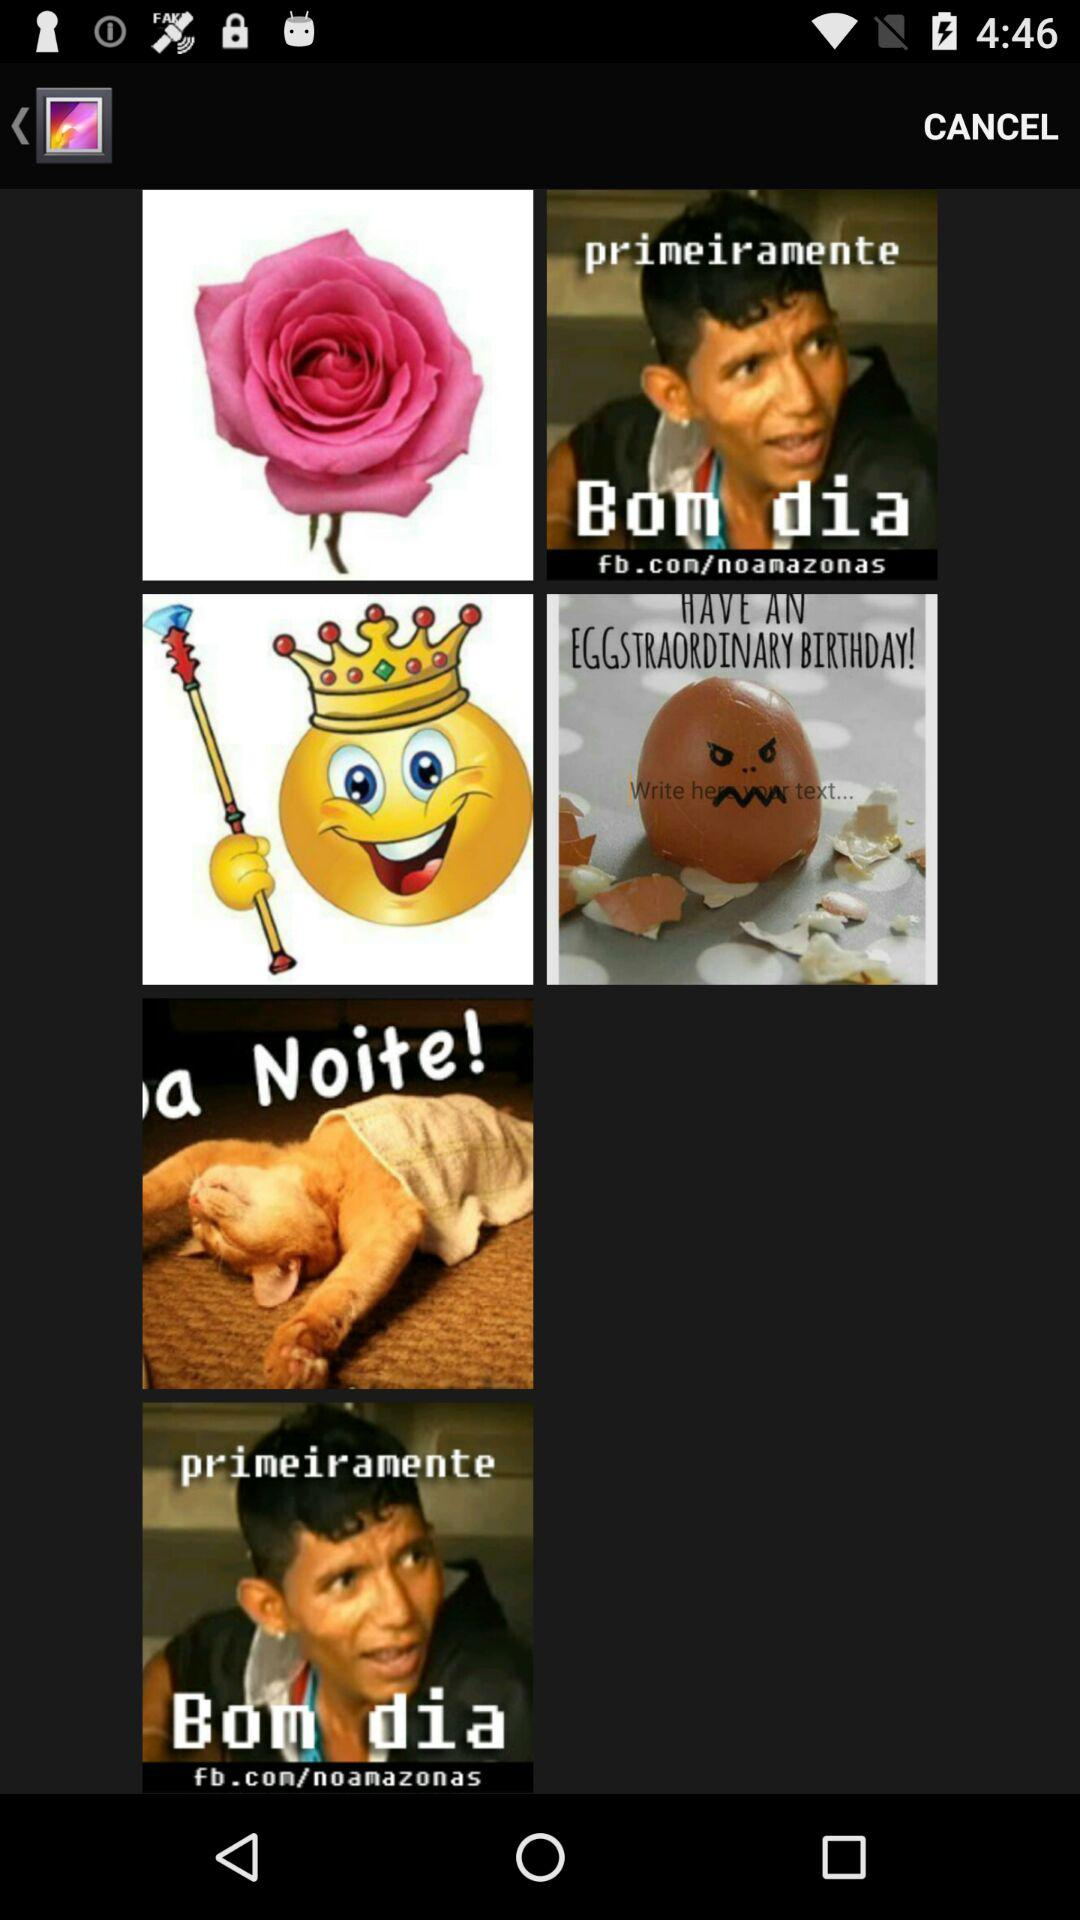How many items have the text 'Bom dia'?
Answer the question using a single word or phrase. 2 